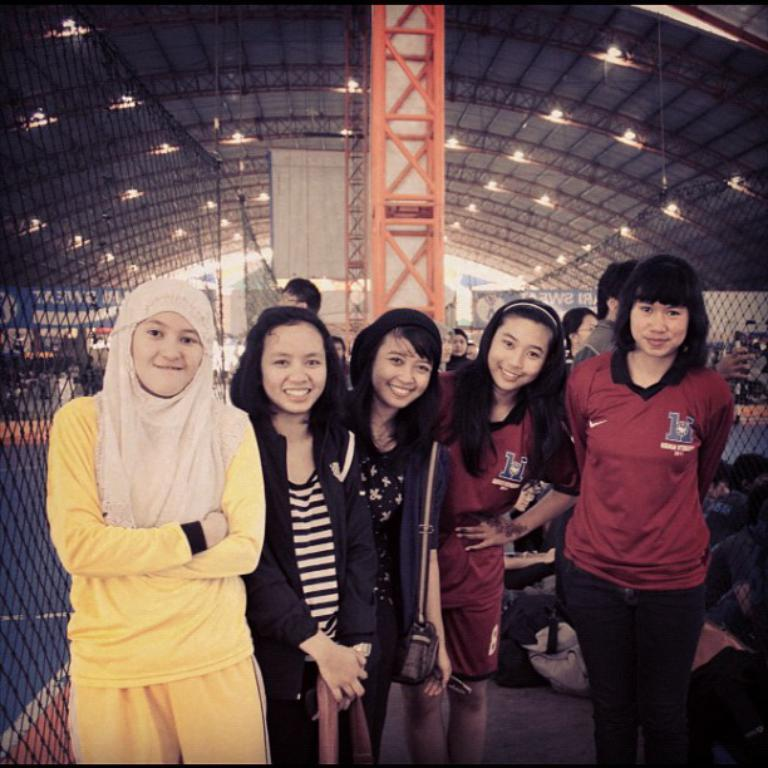What can be seen in the image involving multiple people? There is a group of women in the image. What are the women doing in the image? The women are posing for a photo. What is located on the left side of the image? There is a mesh on the left side of the image. What is above the women in the image? There is a big roof above the women. What type of ball is being used by the queen in the image? There is no queen or ball present in the image. Can you tell me what the women are writing in their notebooks during the photo session? There are no notebooks visible in the image; the women are simply posing for a photo. 